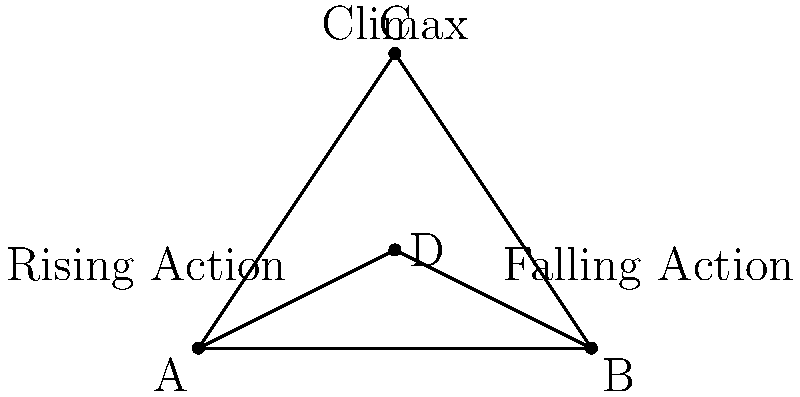In this plot diagram, the rising and falling action lines intersect at point D, forming two angles. If the angle of the rising action (∠ACD) is 60°, what is the measure of the angle formed by the falling action (∠BCD)? To solve this problem, let's follow these steps:

1. Recognize that the diagram forms a triangle ABC, with point D on the base.

2. Recall that the sum of angles in a triangle is always 180°.

3. The angle at the top of the triangle (∠ACB) represents the climax of the story. This angle is split into two parts by the line AD:
   - ∠ACD (rising action) = 60° (given)
   - ∠BCD (falling action) = x° (what we need to find)

4. The sum of these two angles must equal ∠ACB:
   $60° + x° = ∠ACB$

5. In a triangle, the line from a vertex to the midpoint of the opposite side (like AD in this case) creates two equal angles at the base. This means:
   $∠CAD = ∠CBD$

6. Let's call each of these base angles y°. We can now write:
   $y° + y° + 60° + x° = 180°$
   $2y° + 60° + x° = 180°$

7. We don't know the value of y, but we don't need to. We can simplify:
   $60° + x° = 180° - 2y°$

8. Remember from step 4 that $60° + x° = ∠ACB$. This means:
   $∠ACB = 180° - 2y°$

9. The only way this equation works is if $2y° = 0°$, which means $y = 0$.

10. Therefore, $∠ACB = 180°$

11. Finally, we can solve for x:
    $60° + x° = 180°$
    $x° = 180° - 60° = 120°$

Thus, the measure of the angle formed by the falling action (∠BCD) is 120°.
Answer: 120° 